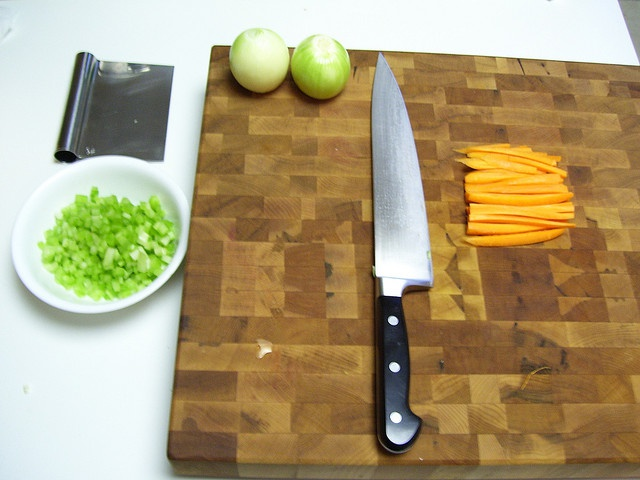Describe the objects in this image and their specific colors. I can see dining table in lightgray, white, and darkgray tones, bowl in lightgray, ivory, lightgreen, and olive tones, knife in lightgray, darkgray, and black tones, apple in lightgray, lightyellow, khaki, and olive tones, and apple in lightgray, olive, lightyellow, lightgreen, and khaki tones in this image. 